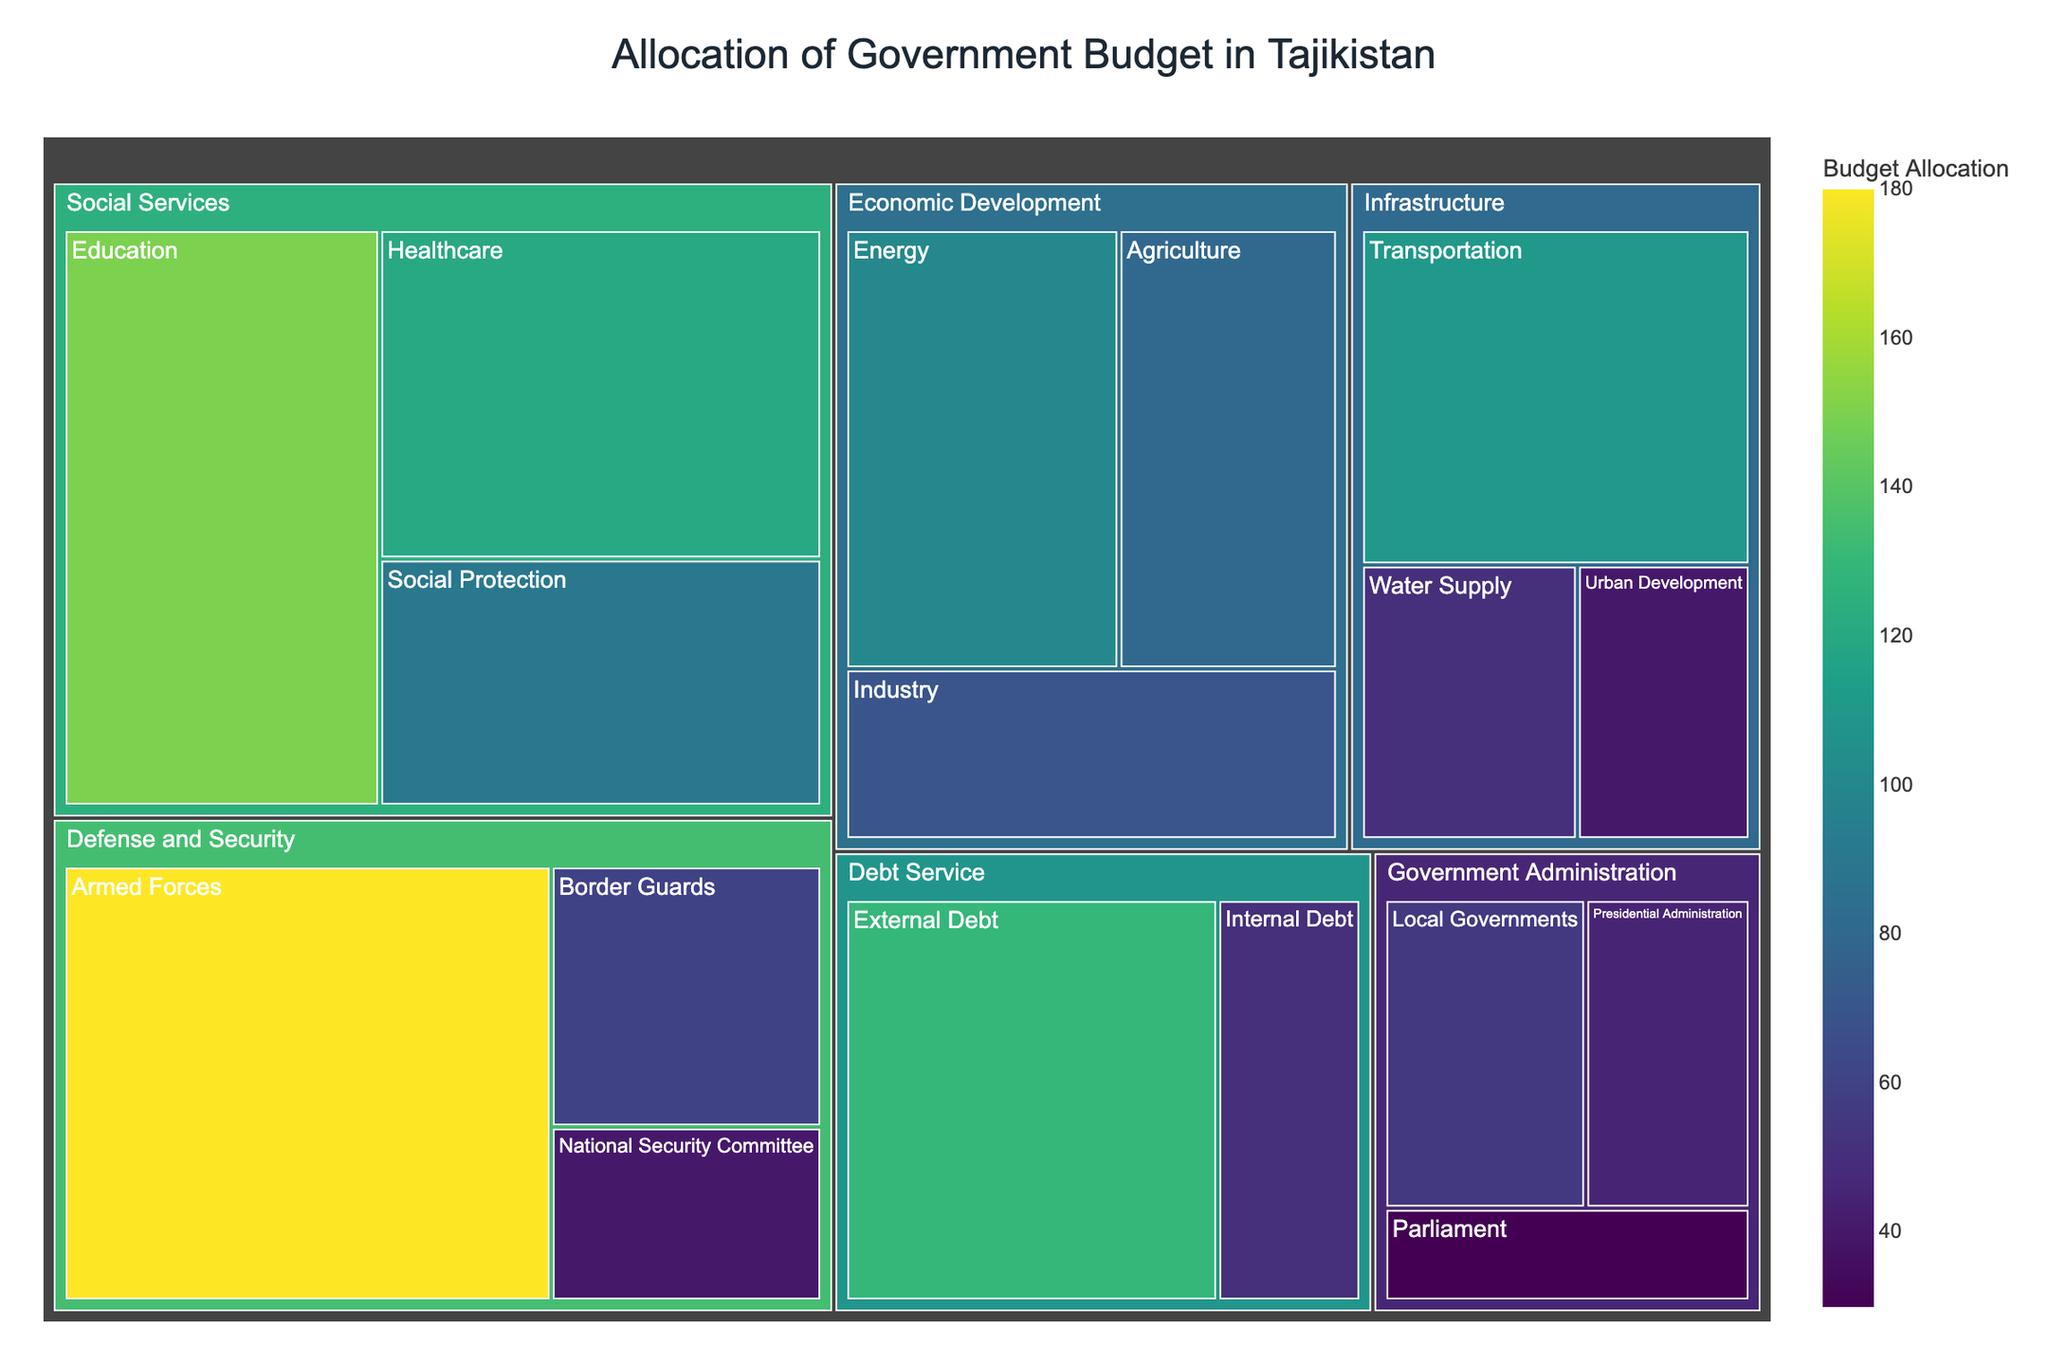What is the title of the treemap? The title is usually displayed at the top of the figure, and it helps describe the main subject of the visualization. Here, it is written clearly.
Answer: Allocation of Government Budget in Tajikistan Which sector receives the highest budget allocation? By looking for the largest segments in the treemap and checking their values, the dominant color section often indicates the sector with the highest allocation. In this case, it's the Defense and Security sector.
Answer: Defense and Security How much budget is allocated to Social Services? Sum the budget allocations of the subsectors within Social Services: Education (150) + Healthcare (120) + Social Protection (90).
Answer: 360 million TJS Which subsector within Economic Development has the highest budget allocation? Within the Economic Development sector, compare the values of the subsectors Agriculture (80), Industry (70), and Energy (100) to identify the highest.
Answer: Energy What is the total budget allocated to Infrastructure? Sum up the values for Transportation (110), Water Supply (50), and Urban Development (40).
Answer: 200 million TJS Is the budget allocation for Internal Debt higher or lower than External Debt? Compare the values for Internal Debt (50) and External Debt (130).
Answer: Lower Which subsector within Defense and Security has the smallest budget allocation? Analyze the values within the Defense and Security sector: Armed Forces (180), Border Guards (60), and National Security Committee (40).
Answer: National Security Committee Does Education receive a higher budget allocation than Agriculture? Compare the budget allocation values for Education (150) and Agriculture (80).
Answer: Higher How does the budget allocation for Local Governments compare to that of Border Guards? Compare the budget values for Local Governments (55) and Border Guards (60).
Answer: Lower What are the subsectors under Government Administration and their respective budget allocations? Identify and list the subsectors and their values within the Government Administration sector: Presidential Administration (45), Parliament (30), and Local Governments (55).
Answer: Presidential Administration (45), Parliament (30), Local Governments (55) 